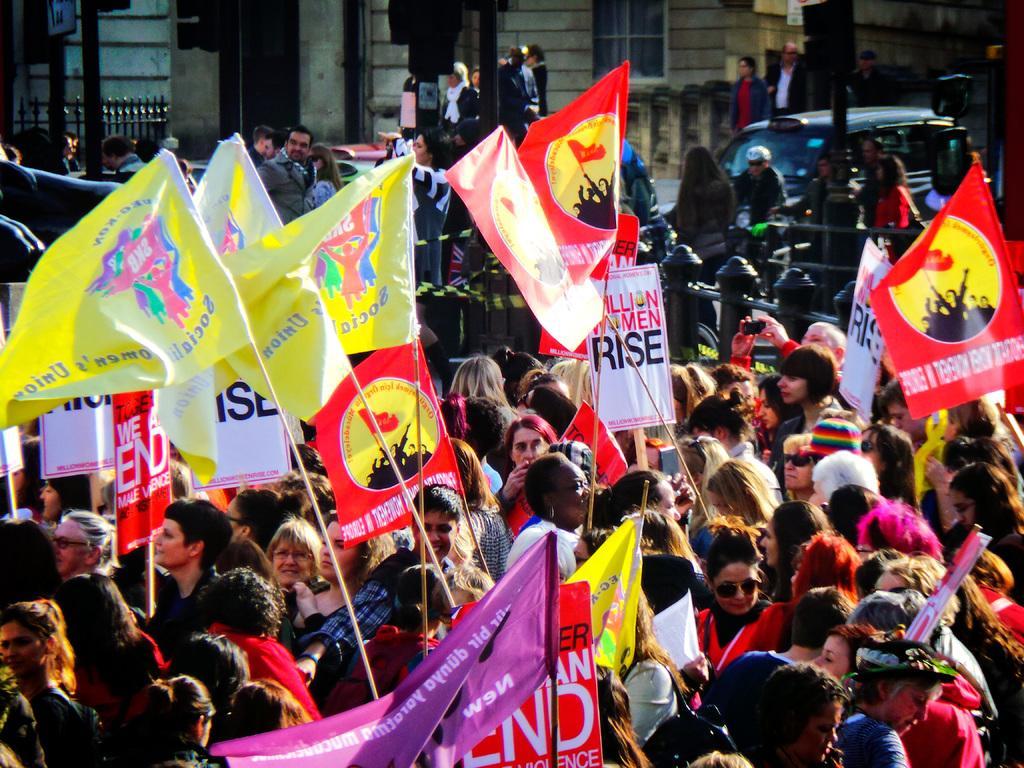In one or two sentences, can you explain what this image depicts? In this teacher we can see the group of persons were holding a flag. In the background there is a vehicle which is parked near to the poles, beside that there are two persons were walking on the road. At the top we can see the building. In the top left corner there is a fencing, beside that we can see black pole. 